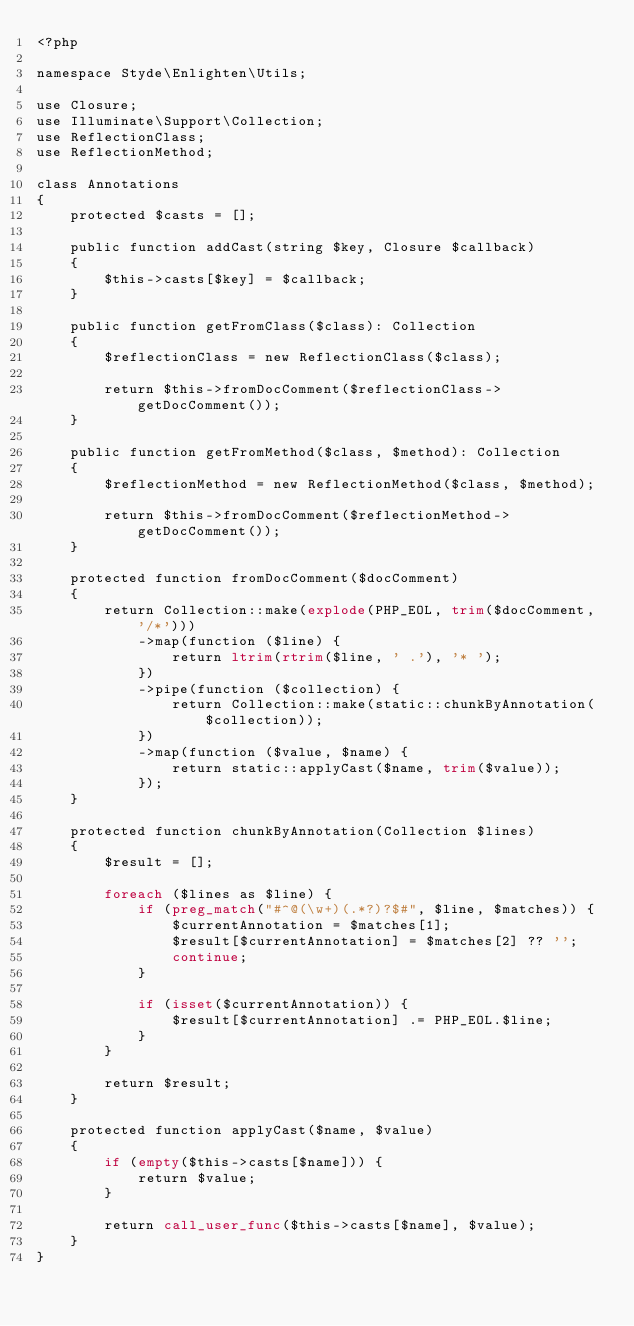Convert code to text. <code><loc_0><loc_0><loc_500><loc_500><_PHP_><?php

namespace Styde\Enlighten\Utils;

use Closure;
use Illuminate\Support\Collection;
use ReflectionClass;
use ReflectionMethod;

class Annotations
{
    protected $casts = [];

    public function addCast(string $key, Closure $callback)
    {
        $this->casts[$key] = $callback;
    }

    public function getFromClass($class): Collection
    {
        $reflectionClass = new ReflectionClass($class);

        return $this->fromDocComment($reflectionClass->getDocComment());
    }

    public function getFromMethod($class, $method): Collection
    {
        $reflectionMethod = new ReflectionMethod($class, $method);

        return $this->fromDocComment($reflectionMethod->getDocComment());
    }

    protected function fromDocComment($docComment)
    {
        return Collection::make(explode(PHP_EOL, trim($docComment, '/*')))
            ->map(function ($line) {
                return ltrim(rtrim($line, ' .'), '* ');
            })
            ->pipe(function ($collection) {
                return Collection::make(static::chunkByAnnotation($collection));
            })
            ->map(function ($value, $name) {
                return static::applyCast($name, trim($value));
            });
    }

    protected function chunkByAnnotation(Collection $lines)
    {
        $result = [];

        foreach ($lines as $line) {
            if (preg_match("#^@(\w+)(.*?)?$#", $line, $matches)) {
                $currentAnnotation = $matches[1];
                $result[$currentAnnotation] = $matches[2] ?? '';
                continue;
            }

            if (isset($currentAnnotation)) {
                $result[$currentAnnotation] .= PHP_EOL.$line;
            }
        }

        return $result;
    }

    protected function applyCast($name, $value)
    {
        if (empty($this->casts[$name])) {
            return $value;
        }

        return call_user_func($this->casts[$name], $value);
    }
}
</code> 